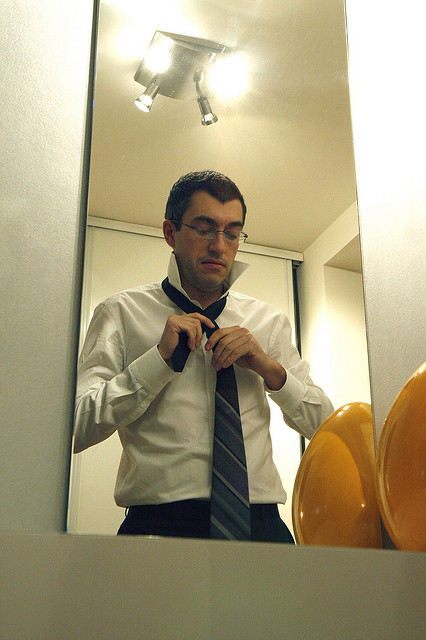Consider this man is actually a spy on a mission. How does his preparation differ now? If the man were a spy on a mission, his actions would take on a more urgent and calculated tone. Adjusting the necktie could be about ensuring any hidden gadgets or communication devices are properly concealed. His formal attire would be part of his cover, helping him blend into a high-profile event or meeting. The intense focus in his expression would reflect the high stakes of his upcoming mission. What if the mirror was actually a portal to another dimension? Describe a scenario. If the mirror were a portal to another dimension, the man’s actions would be a ritual of activation. As he adjusts his necktie, the mirror begins to shimmer and glow, revealing glimpses of an alternate universe. Once his preparation is complete, he steps forward, merging into the portal. On the other side, he emerges in a parallel world where he assumes a different identity, navigating a blend of familiar and fantastical landscapes in a quest that intertwines both realities. Think of a realistic scenario where the man might be late for an event. How does this change his demeanor? If the man were late for an event, his demeanor would likely be more hurried and stressed. He would glance frequently at a clock or his wristwatch, his movements quick and slightly frantic as he adjusts his necktie. The focus and calmness noted in the original image would shift to a sense of urgency, perhaps even frustration at his tardiness. Imagine he just received an important call while adjusting his tie. How would this impact the scene? If the man received an important call while adjusting his tie, the scene would depict a multitasking scenario. He might pause for a moment, holding his phone with one hand while continuing to adjust his tie with the other. His expression could shift to concentration or concern, depending on the nature of the call. This addition would add an element of dynamic urgency to the otherwise calm preparation scene. 